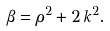Convert formula to latex. <formula><loc_0><loc_0><loc_500><loc_500>\beta = \rho ^ { 2 } + 2 \, k ^ { 2 } .</formula> 